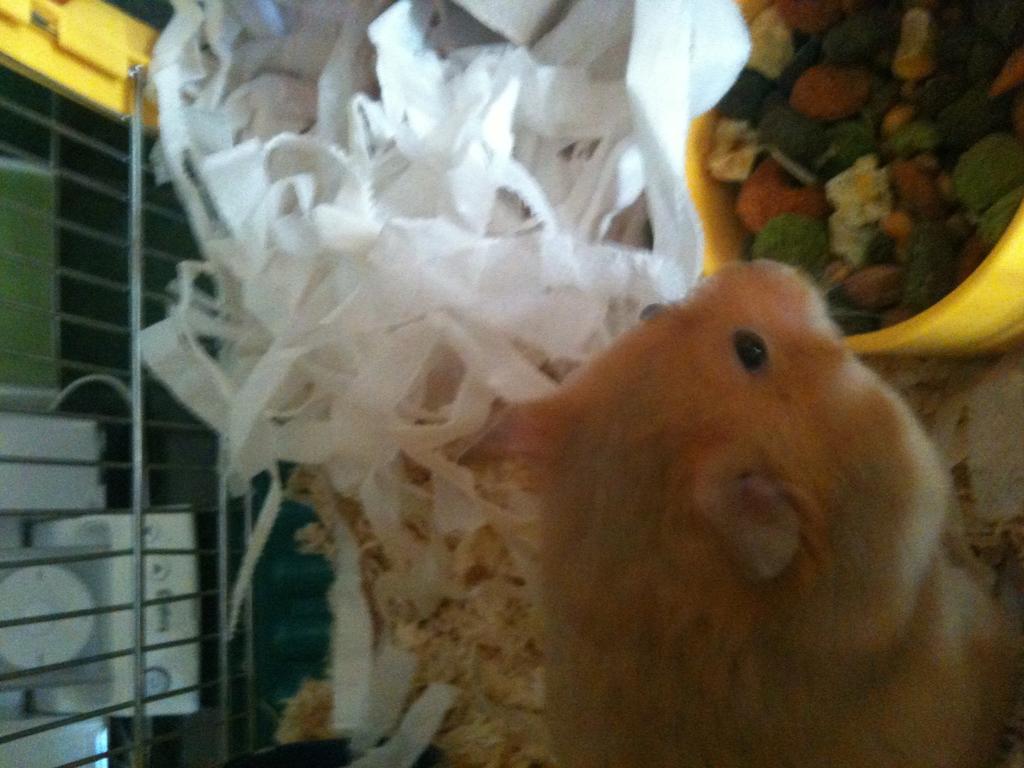How would you summarize this image in a sentence or two? In this picture we can see an animal, cloth pieces, rods, bowl and some objects. 